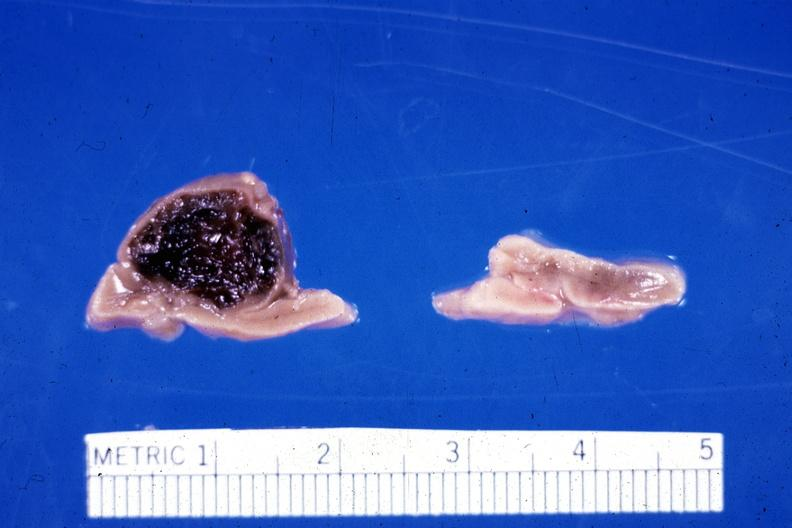what had fixed tissue hemorrhage hematoma in left adrenal of premature 30 week gestation gram infant lesion ruptured causing?
Answer the question using a single word or phrase. Ruptured 20 ml hemoperitoneum unusual 